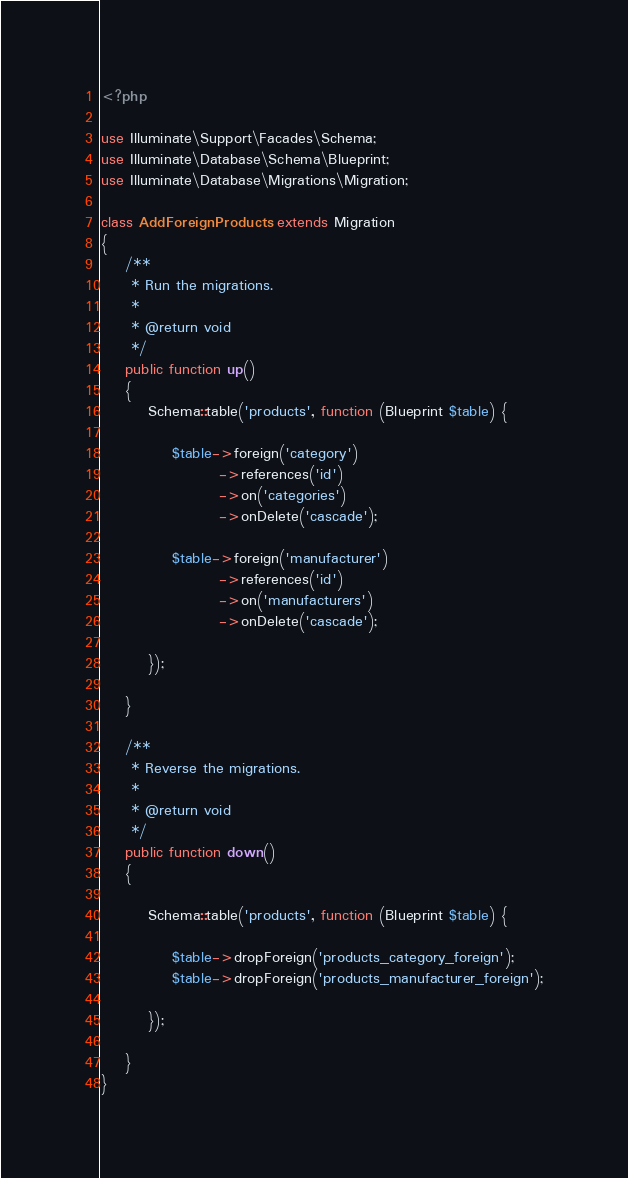Convert code to text. <code><loc_0><loc_0><loc_500><loc_500><_PHP_><?php

use Illuminate\Support\Facades\Schema;
use Illuminate\Database\Schema\Blueprint;
use Illuminate\Database\Migrations\Migration;

class AddForeignProducts extends Migration
{
    /**
     * Run the migrations.
     *
     * @return void
     */
    public function up()
    {
        Schema::table('products', function (Blueprint $table) {

            $table->foreign('category')
                    ->references('id')
                    ->on('categories')
                    ->onDelete('cascade');

            $table->foreign('manufacturer')
                    ->references('id')
                    ->on('manufacturers')
                    ->onDelete('cascade');

        });

    }

    /**
     * Reverse the migrations.
     *
     * @return void
     */
    public function down()
    {

        Schema::table('products', function (Blueprint $table) {

            $table->dropForeign('products_category_foreign');
            $table->dropForeign('products_manufacturer_foreign');

        });

    }
}
</code> 